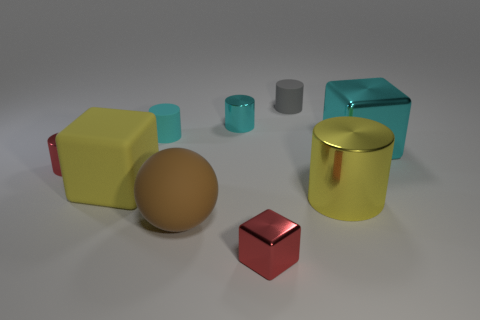What is the shape of the thing that is the same color as the small cube?
Offer a terse response. Cylinder. Does the tiny rubber cylinder on the right side of the big brown thing have the same color as the cube that is on the right side of the gray cylinder?
Offer a terse response. No. Is the number of tiny shiny objects in front of the large brown ball greater than the number of gray cylinders?
Your answer should be very brief. No. What material is the small red block?
Your answer should be very brief. Metal. The large cyan thing that is made of the same material as the yellow cylinder is what shape?
Provide a short and direct response. Cube. How big is the red metallic thing to the left of the block that is in front of the yellow matte block?
Your response must be concise. Small. The object right of the large cylinder is what color?
Provide a succinct answer. Cyan. Are there any cyan shiny things of the same shape as the yellow matte object?
Provide a succinct answer. Yes. Is the number of big cubes in front of the big yellow block less than the number of red objects that are in front of the brown matte thing?
Provide a succinct answer. Yes. The small cube is what color?
Provide a succinct answer. Red. 